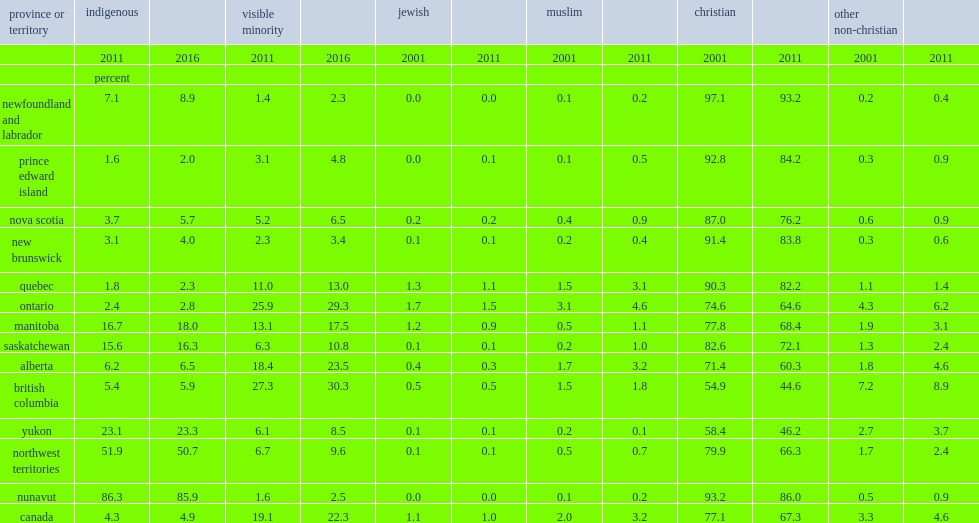What was the percentage of the jewish population remained stable? 1.0. What the percentage of the canadian population reported affiliation with a christian religion? 67.3. 